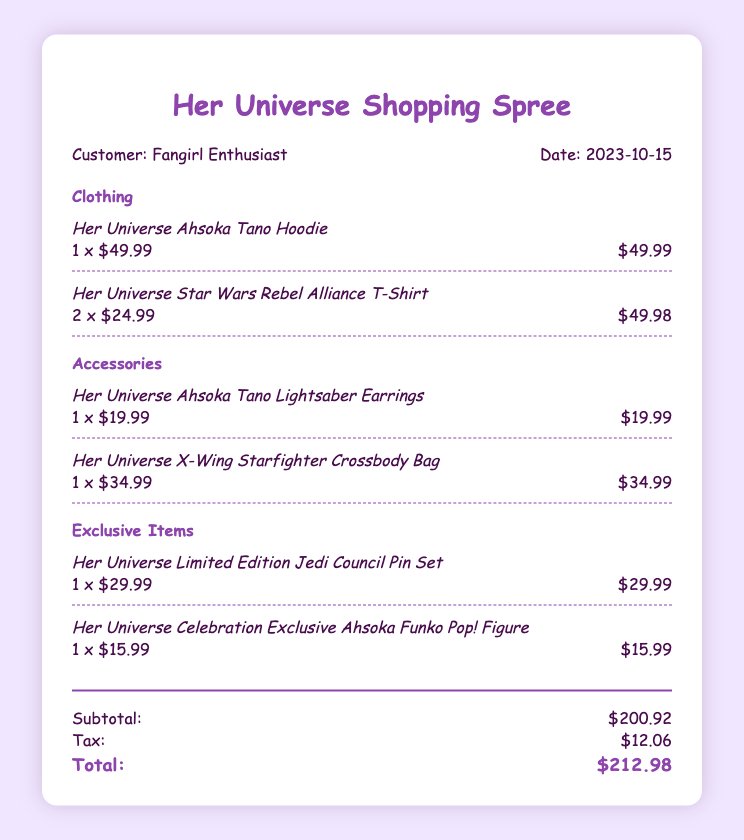what is the date of the shopping spree? The date is noted in the header of the document, which indicates the shopping spree took place on October 15, 2023.
Answer: 2023-10-15 who is the customer listed on the bill? The customer's name is displayed in the header section, identifying them as "Fangirl Enthusiast."
Answer: Fangirl Enthusiast how many Rebel Alliance T-shirts were purchased? The document details the purchases and states that two Rebel Alliance T-shirts were bought.
Answer: 2 what is the price of the Ahsoka Tano Hoodie? The price for the Ahsoka Tano Hoodie is provided within the clothing section of the document, which indicates its cost.
Answer: $49.99 what is the subtotal amount for all items before tax? The subtotal is calculated and shown in the summary section, totaling the prices of all items before tax is applied.
Answer: $200.92 which exclusive item features an Ahsoka Funko Pop! Figure? The document specifically names a Funko Pop! Figure in the exclusive items section, indicating its identity.
Answer: Her Universe Celebration Exclusive Ahsoka Funko Pop! Figure how much was paid in tax? The tax amount is clearly listed in the summary section as an additional cost on top of the subtotal.
Answer: $12.06 what is the total amount spent including tax? The total is the final amount presented in the summary section, combining subtotal and tax for a complete cost.
Answer: $212.98 how many items are categorized under accessories? The accessories section lists two items, indicating the total in that category.
Answer: 2 